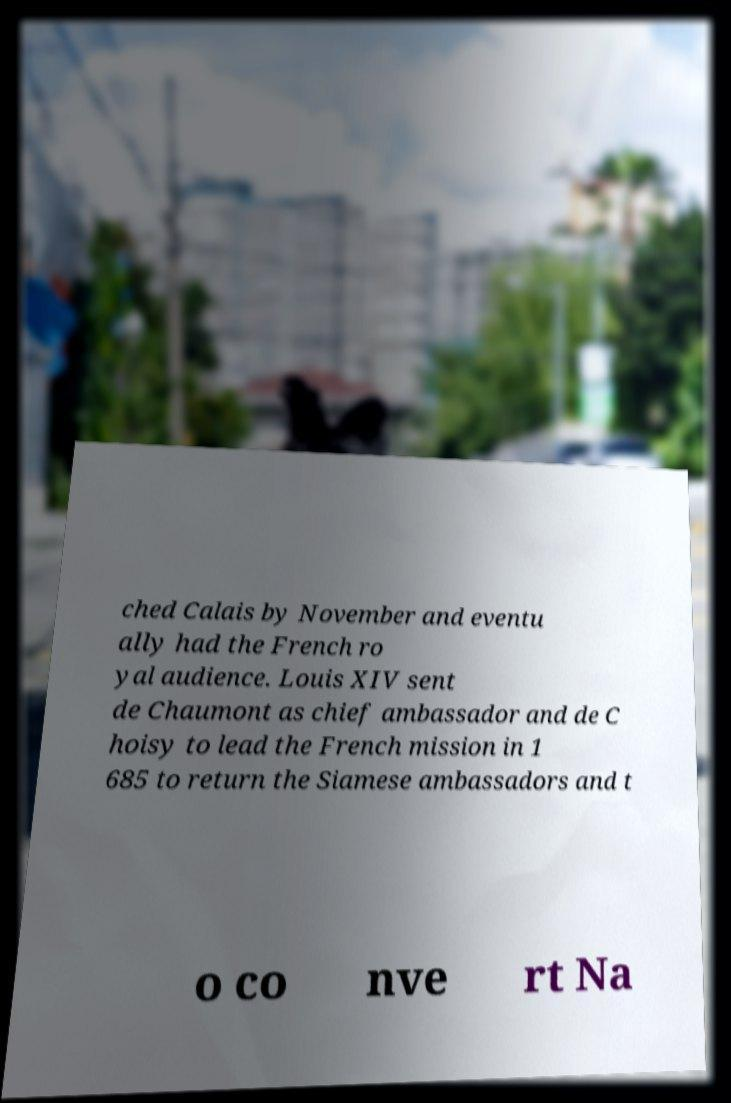Please identify and transcribe the text found in this image. ched Calais by November and eventu ally had the French ro yal audience. Louis XIV sent de Chaumont as chief ambassador and de C hoisy to lead the French mission in 1 685 to return the Siamese ambassadors and t o co nve rt Na 